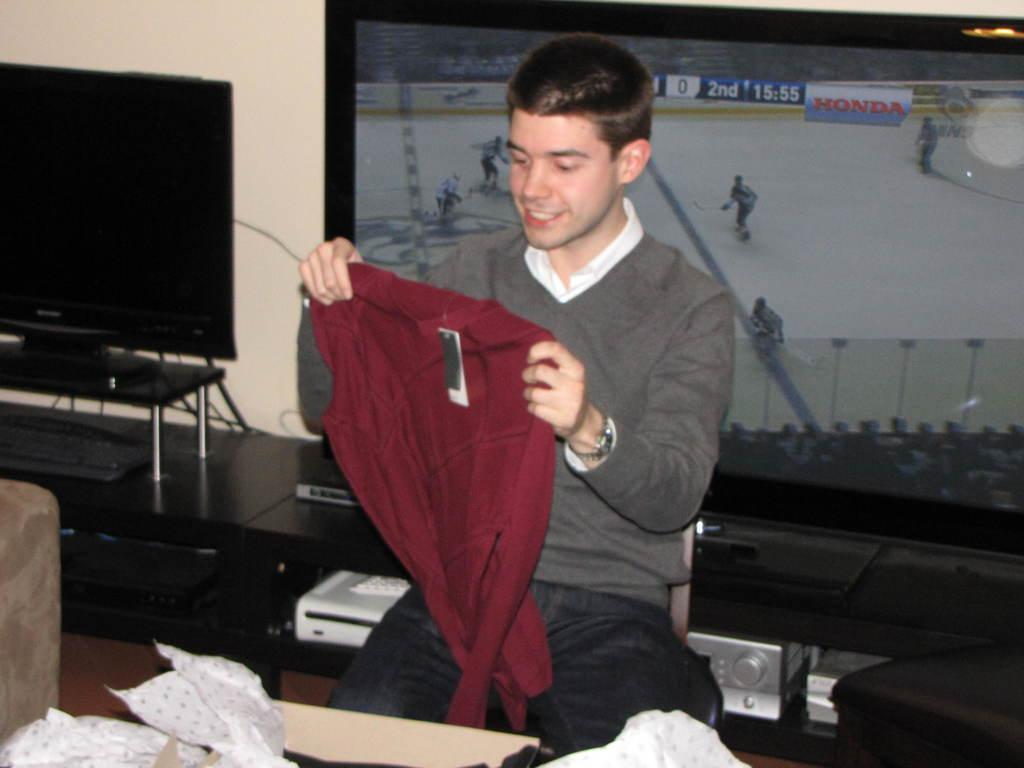<image>
Give a short and clear explanation of the subsequent image. A man is holding a sweater with an ice hocky game sponsored by Honda playing on the television behind him. 